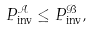<formula> <loc_0><loc_0><loc_500><loc_500>P _ { \text {inv} } ^ { \mathcal { A } } \leq P _ { \text {inv} } ^ { \mathcal { B } } ,</formula> 